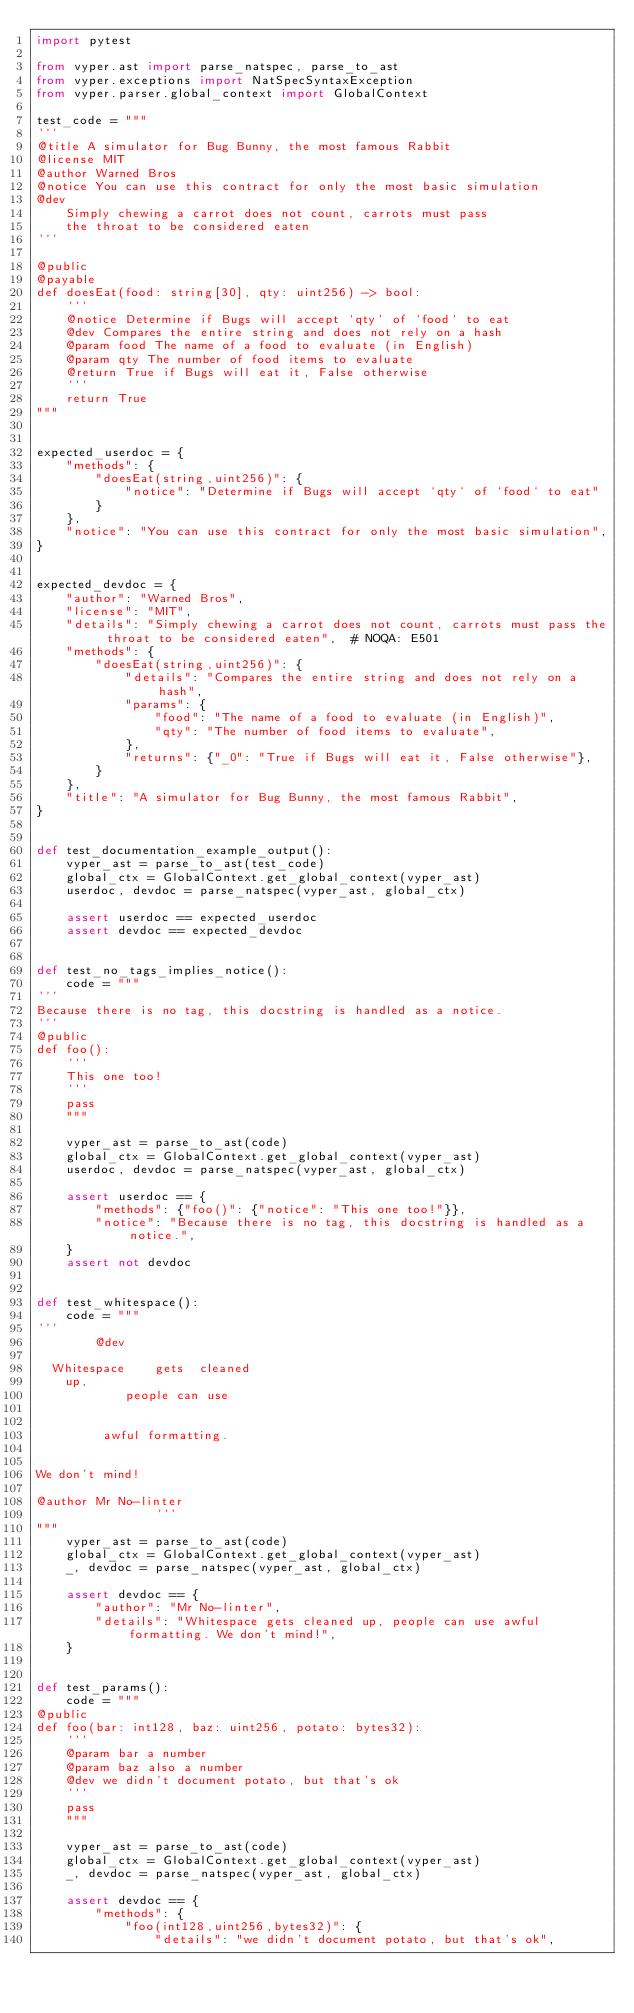<code> <loc_0><loc_0><loc_500><loc_500><_Python_>import pytest

from vyper.ast import parse_natspec, parse_to_ast
from vyper.exceptions import NatSpecSyntaxException
from vyper.parser.global_context import GlobalContext

test_code = """
'''
@title A simulator for Bug Bunny, the most famous Rabbit
@license MIT
@author Warned Bros
@notice You can use this contract for only the most basic simulation
@dev
    Simply chewing a carrot does not count, carrots must pass
    the throat to be considered eaten
'''

@public
@payable
def doesEat(food: string[30], qty: uint256) -> bool:
    '''
    @notice Determine if Bugs will accept `qty` of `food` to eat
    @dev Compares the entire string and does not rely on a hash
    @param food The name of a food to evaluate (in English)
    @param qty The number of food items to evaluate
    @return True if Bugs will eat it, False otherwise
    '''
    return True
"""


expected_userdoc = {
    "methods": {
        "doesEat(string,uint256)": {
            "notice": "Determine if Bugs will accept `qty` of `food` to eat"
        }
    },
    "notice": "You can use this contract for only the most basic simulation",
}


expected_devdoc = {
    "author": "Warned Bros",
    "license": "MIT",
    "details": "Simply chewing a carrot does not count, carrots must pass the throat to be considered eaten",  # NOQA: E501
    "methods": {
        "doesEat(string,uint256)": {
            "details": "Compares the entire string and does not rely on a hash",
            "params": {
                "food": "The name of a food to evaluate (in English)",
                "qty": "The number of food items to evaluate",
            },
            "returns": {"_0": "True if Bugs will eat it, False otherwise"},
        }
    },
    "title": "A simulator for Bug Bunny, the most famous Rabbit",
}


def test_documentation_example_output():
    vyper_ast = parse_to_ast(test_code)
    global_ctx = GlobalContext.get_global_context(vyper_ast)
    userdoc, devdoc = parse_natspec(vyper_ast, global_ctx)

    assert userdoc == expected_userdoc
    assert devdoc == expected_devdoc


def test_no_tags_implies_notice():
    code = """
'''
Because there is no tag, this docstring is handled as a notice.
'''
@public
def foo():
    '''
    This one too!
    '''
    pass
    """

    vyper_ast = parse_to_ast(code)
    global_ctx = GlobalContext.get_global_context(vyper_ast)
    userdoc, devdoc = parse_natspec(vyper_ast, global_ctx)

    assert userdoc == {
        "methods": {"foo()": {"notice": "This one too!"}},
        "notice": "Because there is no tag, this docstring is handled as a notice.",
    }
    assert not devdoc


def test_whitespace():
    code = """
'''
        @dev

  Whitespace    gets  cleaned
    up,
            people can use


         awful formatting.


We don't mind!

@author Mr No-linter
                '''
"""
    vyper_ast = parse_to_ast(code)
    global_ctx = GlobalContext.get_global_context(vyper_ast)
    _, devdoc = parse_natspec(vyper_ast, global_ctx)

    assert devdoc == {
        "author": "Mr No-linter",
        "details": "Whitespace gets cleaned up, people can use awful formatting. We don't mind!",
    }


def test_params():
    code = """
@public
def foo(bar: int128, baz: uint256, potato: bytes32):
    '''
    @param bar a number
    @param baz also a number
    @dev we didn't document potato, but that's ok
    '''
    pass
    """

    vyper_ast = parse_to_ast(code)
    global_ctx = GlobalContext.get_global_context(vyper_ast)
    _, devdoc = parse_natspec(vyper_ast, global_ctx)

    assert devdoc == {
        "methods": {
            "foo(int128,uint256,bytes32)": {
                "details": "we didn't document potato, but that's ok",</code> 